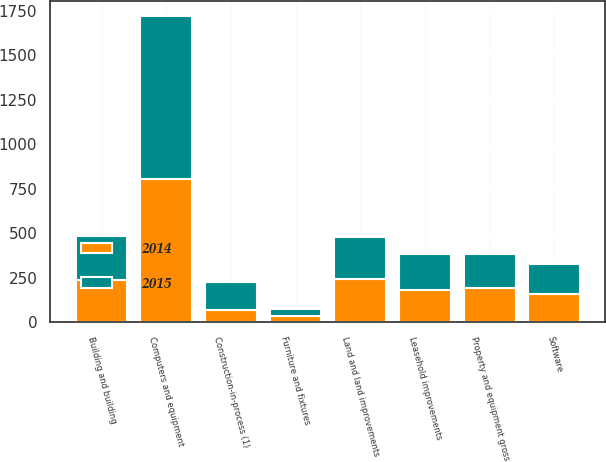Convert chart to OTSL. <chart><loc_0><loc_0><loc_500><loc_500><stacked_bar_chart><ecel><fcel>Computers and equipment<fcel>Software<fcel>Leasehold improvements<fcel>Furniture and fixtures<fcel>Building and building<fcel>Land and land improvements<fcel>Construction-in-process (1)<fcel>Property and equipment gross<nl><fcel>2015<fcel>915.1<fcel>169.1<fcel>203.4<fcel>43.2<fcel>246.1<fcel>241.1<fcel>158.2<fcel>191.45<nl><fcel>2014<fcel>806.1<fcel>161.2<fcel>179.5<fcel>33.7<fcel>238.4<fcel>241<fcel>70.3<fcel>191.45<nl></chart> 